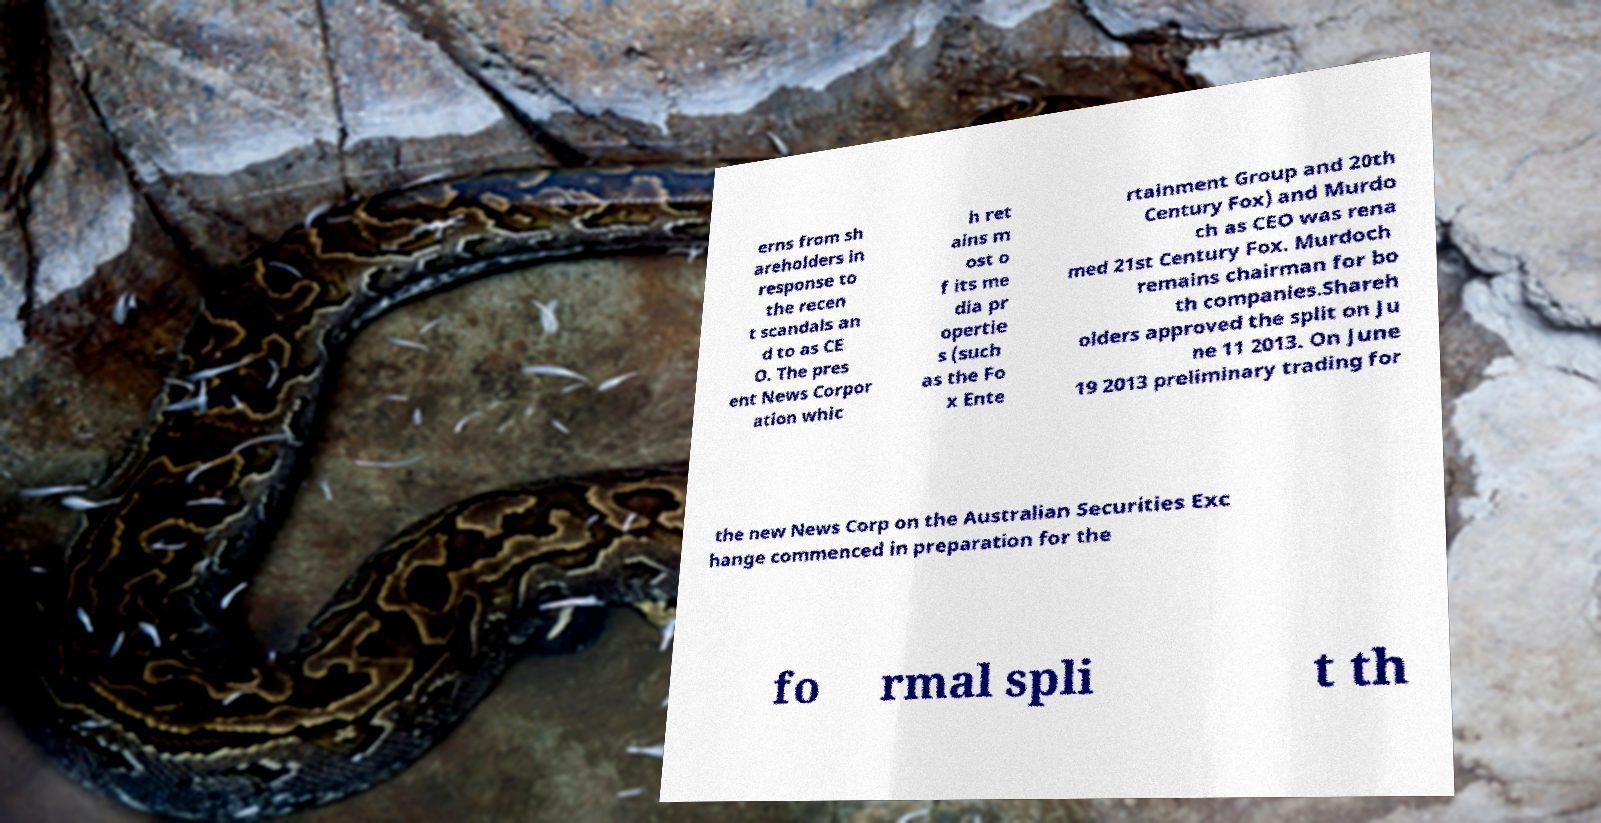There's text embedded in this image that I need extracted. Can you transcribe it verbatim? erns from sh areholders in response to the recen t scandals an d to as CE O. The pres ent News Corpor ation whic h ret ains m ost o f its me dia pr opertie s (such as the Fo x Ente rtainment Group and 20th Century Fox) and Murdo ch as CEO was rena med 21st Century Fox. Murdoch remains chairman for bo th companies.Shareh olders approved the split on Ju ne 11 2013. On June 19 2013 preliminary trading for the new News Corp on the Australian Securities Exc hange commenced in preparation for the fo rmal spli t th 